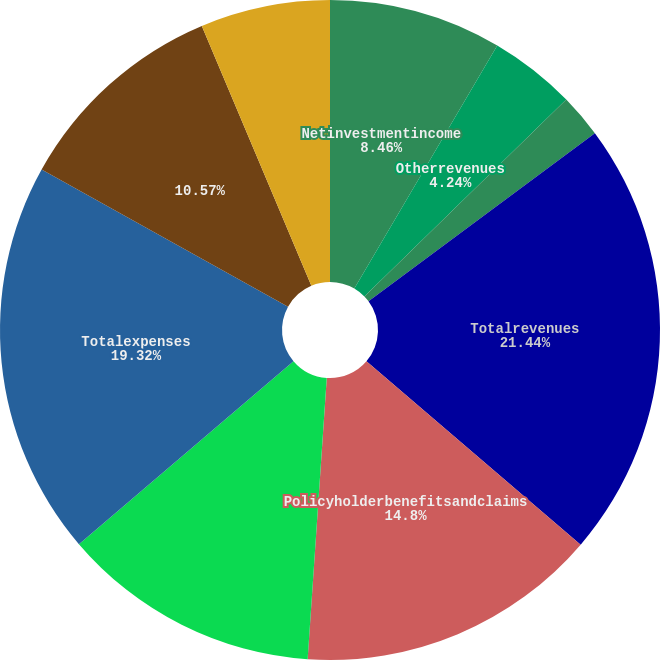Convert chart to OTSL. <chart><loc_0><loc_0><loc_500><loc_500><pie_chart><fcel>Netinvestmentincome<fcel>Otherrevenues<fcel>Netinvestmentgains(losses)<fcel>Totalrevenues<fcel>Policyholderbenefitsandclaims<fcel>Policyholderdividends<fcel>Otherexpenses<fcel>Totalexpenses<fcel>Unnamed: 8<fcel>Provision(benefit)forincometax<nl><fcel>8.46%<fcel>4.24%<fcel>2.13%<fcel>21.44%<fcel>14.8%<fcel>0.01%<fcel>12.68%<fcel>19.32%<fcel>10.57%<fcel>6.35%<nl></chart> 